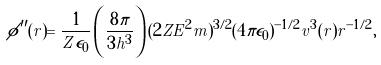Convert formula to latex. <formula><loc_0><loc_0><loc_500><loc_500>\phi ^ { \prime \prime } ( r ) = \frac { 1 } { Z \epsilon _ { 0 } } \left ( \frac { 8 \pi } { 3 h ^ { 3 } } \right ) ( 2 Z E ^ { 2 } m ) ^ { 3 / 2 } ( 4 \pi \epsilon _ { 0 } ) ^ { - 1 / 2 } v ^ { 3 } ( r ) r ^ { - 1 / 2 } ,</formula> 